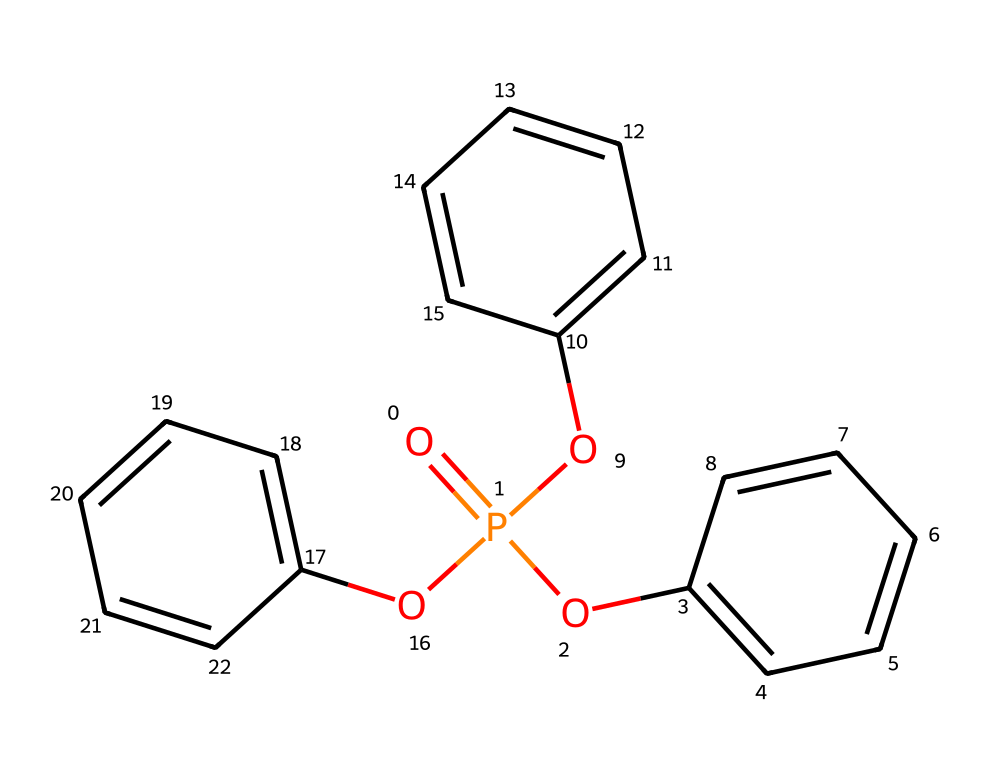What is the total number of aromatic rings in triphenyl phosphate? The chemical structure has three phenyl (benzene) rings visible in the representation. Each phenyl ring is distinct and not connected to the phosphorus atom directly, but are bonded to the phosphate group.
Answer: three How many oxygen atoms are present in the chemical structure? The SMILES representation shows the phosphorus atom bonded to three oxygen atoms, and none are counted in aromatic rings, indicating that there are three oxygen atoms.
Answer: three What functional group is represented by the phosphorus in this compound? The phosphorus atom in triphenyl phosphate is part of a phosphate functional group, which is characterized by the phosphorus atom bonded to four oxygen atoms, one of which is a double bond, fulfilling the structure of phosphate ester in this compound.
Answer: phosphate Is any nitrogen present in this chemical structure? A visual inspection of the SMILES representation shows no nitrogen atoms interconnected with phosphorus, thereby confirming that nitrogen is absent from this compound.
Answer: no What type of compound is triphenyl phosphate? Triphenyl phosphate is classified as a flame retardant, as indicated by its usage mentioned and its structural characteristics, which provide a high level of thermal stability through the presence of three phenyl groups that support its functional properties.
Answer: flame retardant How many phosphorus atoms are in this molecule? Analyzing the SMILES representation reveals a singular phosphorus atom at the core of the phosphate group that is bonded to the three oxygen atoms and the aromatic rings.
Answer: one 